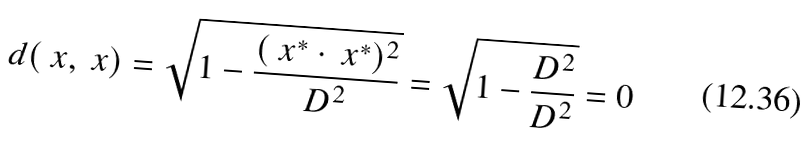Convert formula to latex. <formula><loc_0><loc_0><loc_500><loc_500>d ( \ x , \ x ) = \sqrt { 1 - \frac { ( \ x ^ { * } \cdot \ x ^ { * } ) ^ { 2 } } { D ^ { 2 } } } = \sqrt { 1 - \frac { D ^ { 2 } } { D ^ { 2 } } } = 0</formula> 